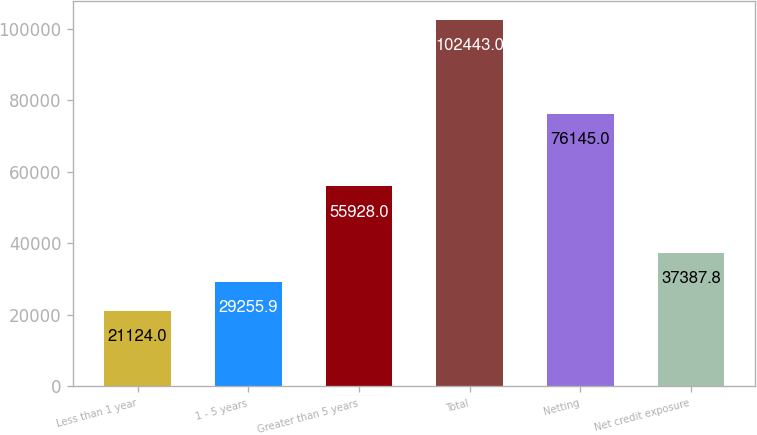Convert chart to OTSL. <chart><loc_0><loc_0><loc_500><loc_500><bar_chart><fcel>Less than 1 year<fcel>1 - 5 years<fcel>Greater than 5 years<fcel>Total<fcel>Netting<fcel>Net credit exposure<nl><fcel>21124<fcel>29255.9<fcel>55928<fcel>102443<fcel>76145<fcel>37387.8<nl></chart> 